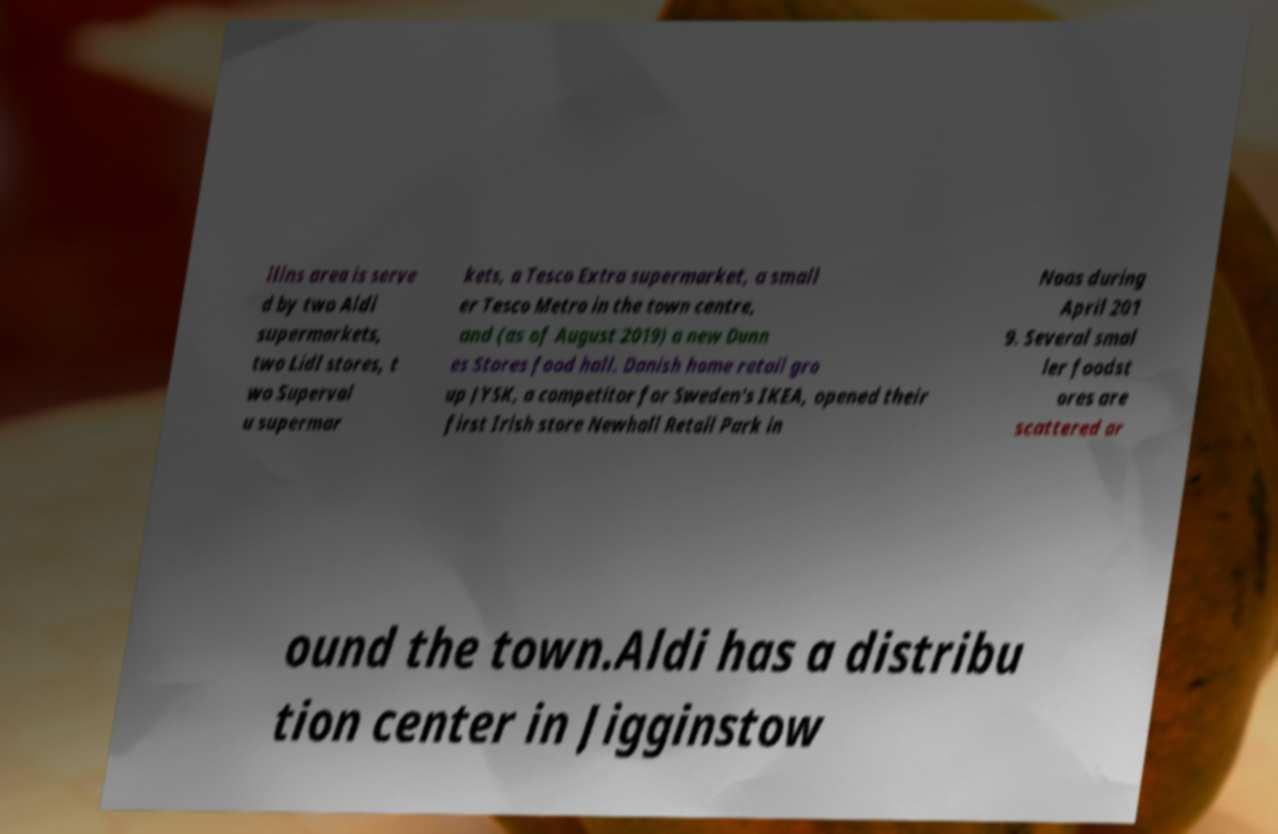Can you accurately transcribe the text from the provided image for me? llins area is serve d by two Aldi supermarkets, two Lidl stores, t wo Superval u supermar kets, a Tesco Extra supermarket, a small er Tesco Metro in the town centre, and (as of August 2019) a new Dunn es Stores food hall. Danish home retail gro up JYSK, a competitor for Sweden's IKEA, opened their first Irish store Newhall Retail Park in Naas during April 201 9. Several smal ler foodst ores are scattered ar ound the town.Aldi has a distribu tion center in Jigginstow 